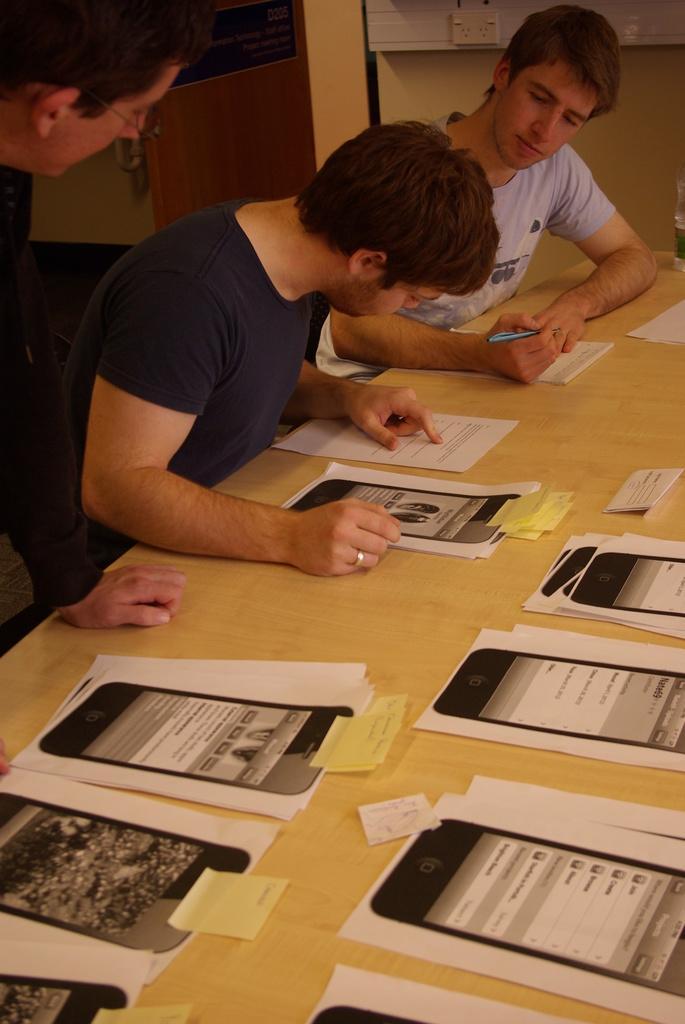Please provide a concise description of this image. In this image there are group of persons. Two persons are sitting in front of a table and one person is standing. On the table there are group of papers placed on it. 